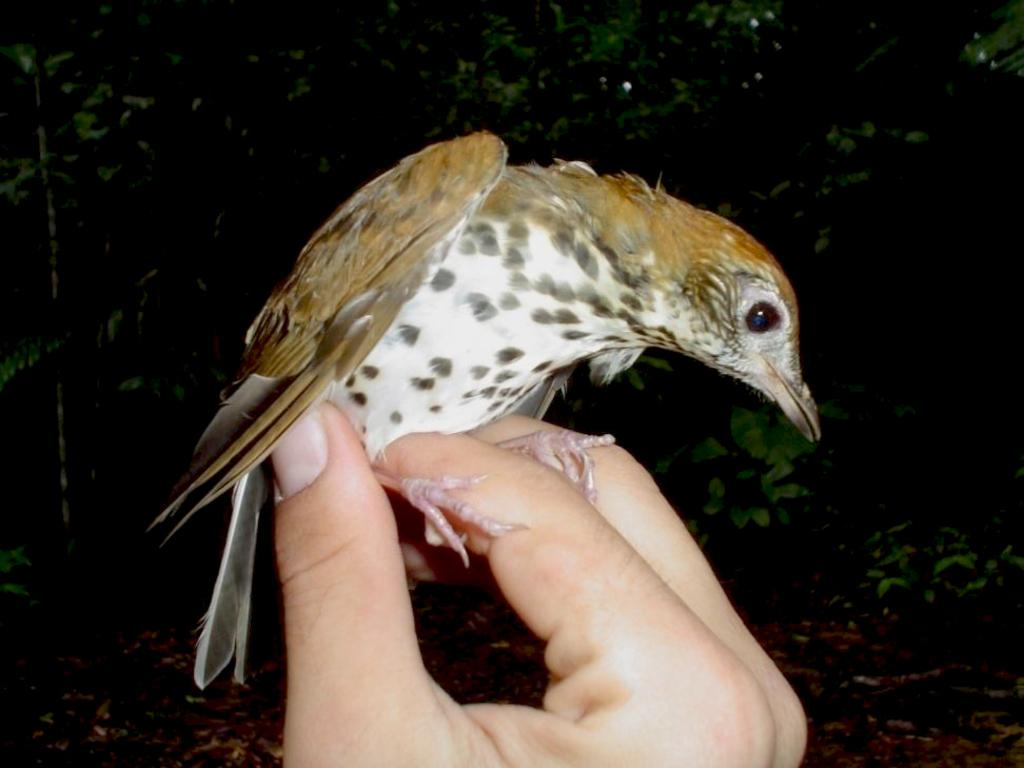What type of animal can be seen in the image? There is a bird in the image. What part of a person is visible in the image? There are fingers visible in the image. What can be seen in the distance in the image? There are trees in the background of the image. How many ducks are visible in the image? There are no ducks present in the image; it features a bird. What type of furniture is shown in the image? There is no furniture present in the image. 